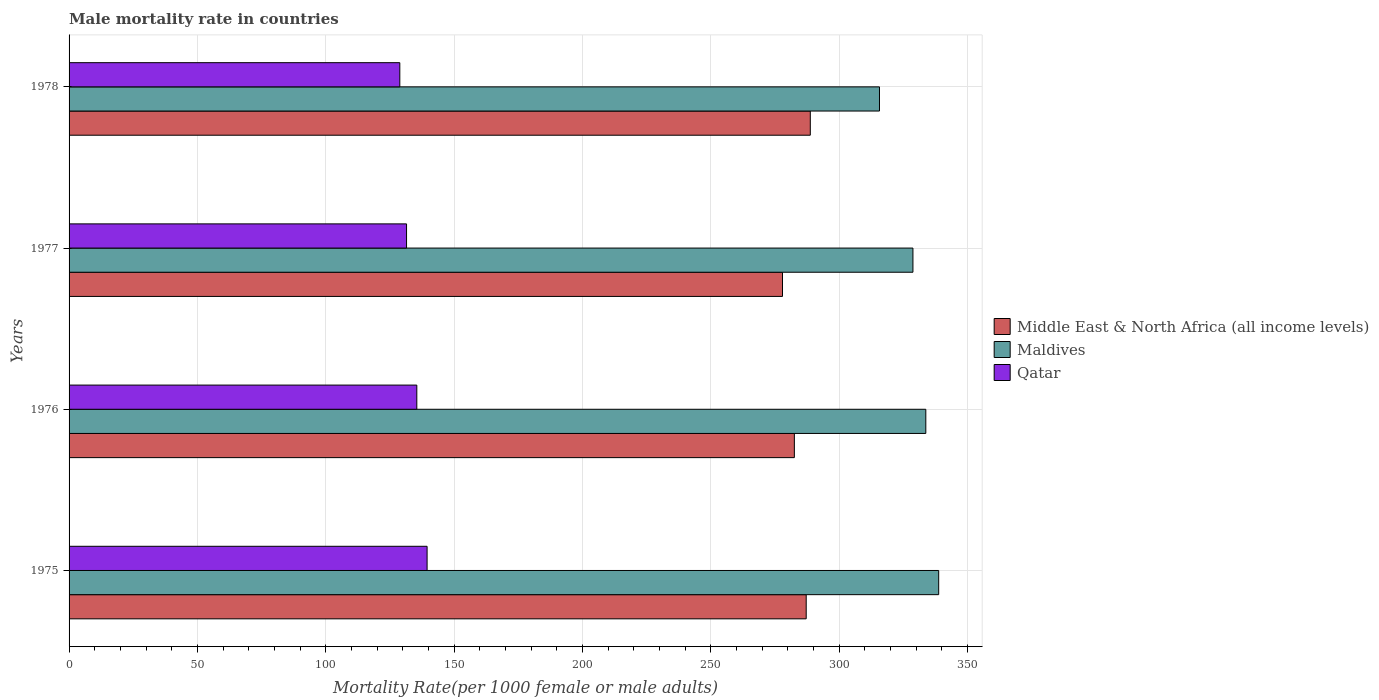How many groups of bars are there?
Ensure brevity in your answer.  4. How many bars are there on the 2nd tick from the top?
Give a very brief answer. 3. What is the label of the 3rd group of bars from the top?
Your answer should be compact. 1976. In how many cases, is the number of bars for a given year not equal to the number of legend labels?
Provide a short and direct response. 0. What is the male mortality rate in Qatar in 1978?
Make the answer very short. 128.85. Across all years, what is the maximum male mortality rate in Middle East & North Africa (all income levels)?
Your answer should be very brief. 288.78. Across all years, what is the minimum male mortality rate in Qatar?
Your answer should be very brief. 128.85. In which year was the male mortality rate in Qatar maximum?
Offer a very short reply. 1975. In which year was the male mortality rate in Qatar minimum?
Keep it short and to the point. 1978. What is the total male mortality rate in Maldives in the graph?
Your response must be concise. 1317.07. What is the difference between the male mortality rate in Middle East & North Africa (all income levels) in 1976 and that in 1977?
Ensure brevity in your answer.  4.62. What is the difference between the male mortality rate in Maldives in 1977 and the male mortality rate in Qatar in 1976?
Make the answer very short. 193.28. What is the average male mortality rate in Middle East & North Africa (all income levels) per year?
Your response must be concise. 284.12. In the year 1977, what is the difference between the male mortality rate in Middle East & North Africa (all income levels) and male mortality rate in Maldives?
Make the answer very short. -50.82. What is the ratio of the male mortality rate in Maldives in 1976 to that in 1977?
Your answer should be compact. 1.02. Is the difference between the male mortality rate in Middle East & North Africa (all income levels) in 1975 and 1977 greater than the difference between the male mortality rate in Maldives in 1975 and 1977?
Offer a terse response. No. What is the difference between the highest and the second highest male mortality rate in Qatar?
Your response must be concise. 4. What is the difference between the highest and the lowest male mortality rate in Maldives?
Your answer should be very brief. 23.06. Is the sum of the male mortality rate in Maldives in 1975 and 1977 greater than the maximum male mortality rate in Qatar across all years?
Give a very brief answer. Yes. What does the 3rd bar from the top in 1977 represents?
Provide a short and direct response. Middle East & North Africa (all income levels). What does the 2nd bar from the bottom in 1975 represents?
Your answer should be compact. Maldives. Is it the case that in every year, the sum of the male mortality rate in Qatar and male mortality rate in Middle East & North Africa (all income levels) is greater than the male mortality rate in Maldives?
Offer a terse response. Yes. Are the values on the major ticks of X-axis written in scientific E-notation?
Provide a succinct answer. No. Does the graph contain any zero values?
Keep it short and to the point. No. Does the graph contain grids?
Make the answer very short. Yes. Where does the legend appear in the graph?
Your answer should be very brief. Center right. What is the title of the graph?
Provide a succinct answer. Male mortality rate in countries. Does "Other small states" appear as one of the legend labels in the graph?
Provide a succinct answer. No. What is the label or title of the X-axis?
Offer a very short reply. Mortality Rate(per 1000 female or male adults). What is the Mortality Rate(per 1000 female or male adults) of Middle East & North Africa (all income levels) in 1975?
Ensure brevity in your answer.  287.18. What is the Mortality Rate(per 1000 female or male adults) of Maldives in 1975?
Provide a succinct answer. 338.79. What is the Mortality Rate(per 1000 female or male adults) in Qatar in 1975?
Provide a short and direct response. 139.48. What is the Mortality Rate(per 1000 female or male adults) of Middle East & North Africa (all income levels) in 1976?
Make the answer very short. 282.57. What is the Mortality Rate(per 1000 female or male adults) of Maldives in 1976?
Your answer should be very brief. 333.78. What is the Mortality Rate(per 1000 female or male adults) in Qatar in 1976?
Offer a very short reply. 135.48. What is the Mortality Rate(per 1000 female or male adults) of Middle East & North Africa (all income levels) in 1977?
Give a very brief answer. 277.95. What is the Mortality Rate(per 1000 female or male adults) in Maldives in 1977?
Your response must be concise. 328.76. What is the Mortality Rate(per 1000 female or male adults) in Qatar in 1977?
Offer a terse response. 131.48. What is the Mortality Rate(per 1000 female or male adults) of Middle East & North Africa (all income levels) in 1978?
Offer a very short reply. 288.78. What is the Mortality Rate(per 1000 female or male adults) in Maldives in 1978?
Offer a very short reply. 315.73. What is the Mortality Rate(per 1000 female or male adults) in Qatar in 1978?
Offer a very short reply. 128.85. Across all years, what is the maximum Mortality Rate(per 1000 female or male adults) in Middle East & North Africa (all income levels)?
Keep it short and to the point. 288.78. Across all years, what is the maximum Mortality Rate(per 1000 female or male adults) of Maldives?
Make the answer very short. 338.79. Across all years, what is the maximum Mortality Rate(per 1000 female or male adults) of Qatar?
Offer a very short reply. 139.48. Across all years, what is the minimum Mortality Rate(per 1000 female or male adults) of Middle East & North Africa (all income levels)?
Your response must be concise. 277.95. Across all years, what is the minimum Mortality Rate(per 1000 female or male adults) of Maldives?
Provide a short and direct response. 315.73. Across all years, what is the minimum Mortality Rate(per 1000 female or male adults) in Qatar?
Make the answer very short. 128.85. What is the total Mortality Rate(per 1000 female or male adults) in Middle East & North Africa (all income levels) in the graph?
Your answer should be compact. 1136.47. What is the total Mortality Rate(per 1000 female or male adults) of Maldives in the graph?
Offer a very short reply. 1317.07. What is the total Mortality Rate(per 1000 female or male adults) in Qatar in the graph?
Keep it short and to the point. 535.29. What is the difference between the Mortality Rate(per 1000 female or male adults) of Middle East & North Africa (all income levels) in 1975 and that in 1976?
Offer a terse response. 4.61. What is the difference between the Mortality Rate(per 1000 female or male adults) of Maldives in 1975 and that in 1976?
Provide a succinct answer. 5.01. What is the difference between the Mortality Rate(per 1000 female or male adults) of Qatar in 1975 and that in 1976?
Offer a very short reply. 4. What is the difference between the Mortality Rate(per 1000 female or male adults) in Middle East & North Africa (all income levels) in 1975 and that in 1977?
Provide a succinct answer. 9.23. What is the difference between the Mortality Rate(per 1000 female or male adults) of Maldives in 1975 and that in 1977?
Offer a very short reply. 10.03. What is the difference between the Mortality Rate(per 1000 female or male adults) in Qatar in 1975 and that in 1977?
Provide a succinct answer. 8. What is the difference between the Mortality Rate(per 1000 female or male adults) of Middle East & North Africa (all income levels) in 1975 and that in 1978?
Make the answer very short. -1.6. What is the difference between the Mortality Rate(per 1000 female or male adults) of Maldives in 1975 and that in 1978?
Offer a terse response. 23.07. What is the difference between the Mortality Rate(per 1000 female or male adults) of Qatar in 1975 and that in 1978?
Your answer should be compact. 10.63. What is the difference between the Mortality Rate(per 1000 female or male adults) of Middle East & North Africa (all income levels) in 1976 and that in 1977?
Make the answer very short. 4.62. What is the difference between the Mortality Rate(per 1000 female or male adults) of Maldives in 1976 and that in 1977?
Provide a short and direct response. 5.01. What is the difference between the Mortality Rate(per 1000 female or male adults) of Qatar in 1976 and that in 1977?
Offer a very short reply. 4. What is the difference between the Mortality Rate(per 1000 female or male adults) of Middle East & North Africa (all income levels) in 1976 and that in 1978?
Your response must be concise. -6.21. What is the difference between the Mortality Rate(per 1000 female or male adults) of Maldives in 1976 and that in 1978?
Ensure brevity in your answer.  18.05. What is the difference between the Mortality Rate(per 1000 female or male adults) of Qatar in 1976 and that in 1978?
Your answer should be compact. 6.63. What is the difference between the Mortality Rate(per 1000 female or male adults) in Middle East & North Africa (all income levels) in 1977 and that in 1978?
Ensure brevity in your answer.  -10.83. What is the difference between the Mortality Rate(per 1000 female or male adults) in Maldives in 1977 and that in 1978?
Your response must be concise. 13.04. What is the difference between the Mortality Rate(per 1000 female or male adults) of Qatar in 1977 and that in 1978?
Offer a terse response. 2.62. What is the difference between the Mortality Rate(per 1000 female or male adults) of Middle East & North Africa (all income levels) in 1975 and the Mortality Rate(per 1000 female or male adults) of Maldives in 1976?
Give a very brief answer. -46.6. What is the difference between the Mortality Rate(per 1000 female or male adults) of Middle East & North Africa (all income levels) in 1975 and the Mortality Rate(per 1000 female or male adults) of Qatar in 1976?
Offer a terse response. 151.7. What is the difference between the Mortality Rate(per 1000 female or male adults) in Maldives in 1975 and the Mortality Rate(per 1000 female or male adults) in Qatar in 1976?
Your response must be concise. 203.31. What is the difference between the Mortality Rate(per 1000 female or male adults) in Middle East & North Africa (all income levels) in 1975 and the Mortality Rate(per 1000 female or male adults) in Maldives in 1977?
Give a very brief answer. -41.59. What is the difference between the Mortality Rate(per 1000 female or male adults) in Middle East & North Africa (all income levels) in 1975 and the Mortality Rate(per 1000 female or male adults) in Qatar in 1977?
Keep it short and to the point. 155.7. What is the difference between the Mortality Rate(per 1000 female or male adults) in Maldives in 1975 and the Mortality Rate(per 1000 female or male adults) in Qatar in 1977?
Provide a succinct answer. 207.32. What is the difference between the Mortality Rate(per 1000 female or male adults) in Middle East & North Africa (all income levels) in 1975 and the Mortality Rate(per 1000 female or male adults) in Maldives in 1978?
Make the answer very short. -28.55. What is the difference between the Mortality Rate(per 1000 female or male adults) in Middle East & North Africa (all income levels) in 1975 and the Mortality Rate(per 1000 female or male adults) in Qatar in 1978?
Provide a short and direct response. 158.33. What is the difference between the Mortality Rate(per 1000 female or male adults) in Maldives in 1975 and the Mortality Rate(per 1000 female or male adults) in Qatar in 1978?
Ensure brevity in your answer.  209.94. What is the difference between the Mortality Rate(per 1000 female or male adults) in Middle East & North Africa (all income levels) in 1976 and the Mortality Rate(per 1000 female or male adults) in Maldives in 1977?
Provide a succinct answer. -46.2. What is the difference between the Mortality Rate(per 1000 female or male adults) of Middle East & North Africa (all income levels) in 1976 and the Mortality Rate(per 1000 female or male adults) of Qatar in 1977?
Give a very brief answer. 151.09. What is the difference between the Mortality Rate(per 1000 female or male adults) of Maldives in 1976 and the Mortality Rate(per 1000 female or male adults) of Qatar in 1977?
Provide a short and direct response. 202.3. What is the difference between the Mortality Rate(per 1000 female or male adults) of Middle East & North Africa (all income levels) in 1976 and the Mortality Rate(per 1000 female or male adults) of Maldives in 1978?
Your answer should be compact. -33.16. What is the difference between the Mortality Rate(per 1000 female or male adults) in Middle East & North Africa (all income levels) in 1976 and the Mortality Rate(per 1000 female or male adults) in Qatar in 1978?
Your answer should be compact. 153.71. What is the difference between the Mortality Rate(per 1000 female or male adults) in Maldives in 1976 and the Mortality Rate(per 1000 female or male adults) in Qatar in 1978?
Provide a succinct answer. 204.93. What is the difference between the Mortality Rate(per 1000 female or male adults) in Middle East & North Africa (all income levels) in 1977 and the Mortality Rate(per 1000 female or male adults) in Maldives in 1978?
Offer a terse response. -37.78. What is the difference between the Mortality Rate(per 1000 female or male adults) in Middle East & North Africa (all income levels) in 1977 and the Mortality Rate(per 1000 female or male adults) in Qatar in 1978?
Provide a succinct answer. 149.1. What is the difference between the Mortality Rate(per 1000 female or male adults) in Maldives in 1977 and the Mortality Rate(per 1000 female or male adults) in Qatar in 1978?
Provide a short and direct response. 199.91. What is the average Mortality Rate(per 1000 female or male adults) of Middle East & North Africa (all income levels) per year?
Offer a terse response. 284.12. What is the average Mortality Rate(per 1000 female or male adults) in Maldives per year?
Your answer should be very brief. 329.27. What is the average Mortality Rate(per 1000 female or male adults) in Qatar per year?
Your response must be concise. 133.82. In the year 1975, what is the difference between the Mortality Rate(per 1000 female or male adults) in Middle East & North Africa (all income levels) and Mortality Rate(per 1000 female or male adults) in Maldives?
Provide a succinct answer. -51.62. In the year 1975, what is the difference between the Mortality Rate(per 1000 female or male adults) in Middle East & North Africa (all income levels) and Mortality Rate(per 1000 female or male adults) in Qatar?
Keep it short and to the point. 147.7. In the year 1975, what is the difference between the Mortality Rate(per 1000 female or male adults) in Maldives and Mortality Rate(per 1000 female or male adults) in Qatar?
Your answer should be compact. 199.31. In the year 1976, what is the difference between the Mortality Rate(per 1000 female or male adults) in Middle East & North Africa (all income levels) and Mortality Rate(per 1000 female or male adults) in Maldives?
Make the answer very short. -51.21. In the year 1976, what is the difference between the Mortality Rate(per 1000 female or male adults) of Middle East & North Africa (all income levels) and Mortality Rate(per 1000 female or male adults) of Qatar?
Offer a very short reply. 147.09. In the year 1976, what is the difference between the Mortality Rate(per 1000 female or male adults) in Maldives and Mortality Rate(per 1000 female or male adults) in Qatar?
Keep it short and to the point. 198.3. In the year 1977, what is the difference between the Mortality Rate(per 1000 female or male adults) in Middle East & North Africa (all income levels) and Mortality Rate(per 1000 female or male adults) in Maldives?
Give a very brief answer. -50.82. In the year 1977, what is the difference between the Mortality Rate(per 1000 female or male adults) in Middle East & North Africa (all income levels) and Mortality Rate(per 1000 female or male adults) in Qatar?
Make the answer very short. 146.47. In the year 1977, what is the difference between the Mortality Rate(per 1000 female or male adults) in Maldives and Mortality Rate(per 1000 female or male adults) in Qatar?
Offer a very short reply. 197.29. In the year 1978, what is the difference between the Mortality Rate(per 1000 female or male adults) of Middle East & North Africa (all income levels) and Mortality Rate(per 1000 female or male adults) of Maldives?
Provide a succinct answer. -26.95. In the year 1978, what is the difference between the Mortality Rate(per 1000 female or male adults) of Middle East & North Africa (all income levels) and Mortality Rate(per 1000 female or male adults) of Qatar?
Your response must be concise. 159.93. In the year 1978, what is the difference between the Mortality Rate(per 1000 female or male adults) of Maldives and Mortality Rate(per 1000 female or male adults) of Qatar?
Offer a very short reply. 186.88. What is the ratio of the Mortality Rate(per 1000 female or male adults) of Middle East & North Africa (all income levels) in 1975 to that in 1976?
Ensure brevity in your answer.  1.02. What is the ratio of the Mortality Rate(per 1000 female or male adults) in Maldives in 1975 to that in 1976?
Your response must be concise. 1.01. What is the ratio of the Mortality Rate(per 1000 female or male adults) in Qatar in 1975 to that in 1976?
Keep it short and to the point. 1.03. What is the ratio of the Mortality Rate(per 1000 female or male adults) in Middle East & North Africa (all income levels) in 1975 to that in 1977?
Offer a terse response. 1.03. What is the ratio of the Mortality Rate(per 1000 female or male adults) of Maldives in 1975 to that in 1977?
Make the answer very short. 1.03. What is the ratio of the Mortality Rate(per 1000 female or male adults) of Qatar in 1975 to that in 1977?
Give a very brief answer. 1.06. What is the ratio of the Mortality Rate(per 1000 female or male adults) of Middle East & North Africa (all income levels) in 1975 to that in 1978?
Ensure brevity in your answer.  0.99. What is the ratio of the Mortality Rate(per 1000 female or male adults) in Maldives in 1975 to that in 1978?
Offer a terse response. 1.07. What is the ratio of the Mortality Rate(per 1000 female or male adults) in Qatar in 1975 to that in 1978?
Offer a terse response. 1.08. What is the ratio of the Mortality Rate(per 1000 female or male adults) of Middle East & North Africa (all income levels) in 1976 to that in 1977?
Your answer should be compact. 1.02. What is the ratio of the Mortality Rate(per 1000 female or male adults) in Maldives in 1976 to that in 1977?
Your response must be concise. 1.02. What is the ratio of the Mortality Rate(per 1000 female or male adults) of Qatar in 1976 to that in 1977?
Ensure brevity in your answer.  1.03. What is the ratio of the Mortality Rate(per 1000 female or male adults) of Middle East & North Africa (all income levels) in 1976 to that in 1978?
Offer a very short reply. 0.98. What is the ratio of the Mortality Rate(per 1000 female or male adults) of Maldives in 1976 to that in 1978?
Offer a terse response. 1.06. What is the ratio of the Mortality Rate(per 1000 female or male adults) of Qatar in 1976 to that in 1978?
Provide a short and direct response. 1.05. What is the ratio of the Mortality Rate(per 1000 female or male adults) in Middle East & North Africa (all income levels) in 1977 to that in 1978?
Your response must be concise. 0.96. What is the ratio of the Mortality Rate(per 1000 female or male adults) in Maldives in 1977 to that in 1978?
Provide a succinct answer. 1.04. What is the ratio of the Mortality Rate(per 1000 female or male adults) in Qatar in 1977 to that in 1978?
Provide a succinct answer. 1.02. What is the difference between the highest and the second highest Mortality Rate(per 1000 female or male adults) of Middle East & North Africa (all income levels)?
Your answer should be very brief. 1.6. What is the difference between the highest and the second highest Mortality Rate(per 1000 female or male adults) of Maldives?
Provide a succinct answer. 5.01. What is the difference between the highest and the second highest Mortality Rate(per 1000 female or male adults) in Qatar?
Ensure brevity in your answer.  4. What is the difference between the highest and the lowest Mortality Rate(per 1000 female or male adults) of Middle East & North Africa (all income levels)?
Your answer should be compact. 10.83. What is the difference between the highest and the lowest Mortality Rate(per 1000 female or male adults) of Maldives?
Your answer should be compact. 23.07. What is the difference between the highest and the lowest Mortality Rate(per 1000 female or male adults) of Qatar?
Provide a succinct answer. 10.63. 